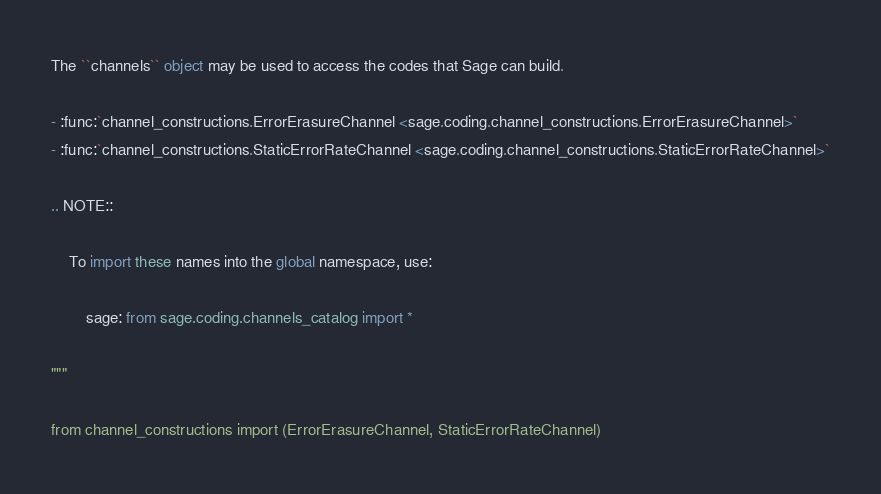Convert code to text. <code><loc_0><loc_0><loc_500><loc_500><_Python_>The ``channels`` object may be used to access the codes that Sage can build.

- :func:`channel_constructions.ErrorErasureChannel <sage.coding.channel_constructions.ErrorErasureChannel>`
- :func:`channel_constructions.StaticErrorRateChannel <sage.coding.channel_constructions.StaticErrorRateChannel>`

.. NOTE::

    To import these names into the global namespace, use:

        sage: from sage.coding.channels_catalog import *

"""

from channel_constructions import (ErrorErasureChannel, StaticErrorRateChannel)
</code> 